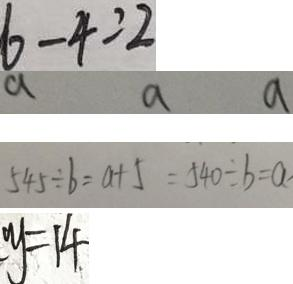<formula> <loc_0><loc_0><loc_500><loc_500>6 - 4 = 2 
 a a a 
 5 4 5 \div b = a + 5 = 5 4 0 \div b = a 
 y = 1 4</formula> 